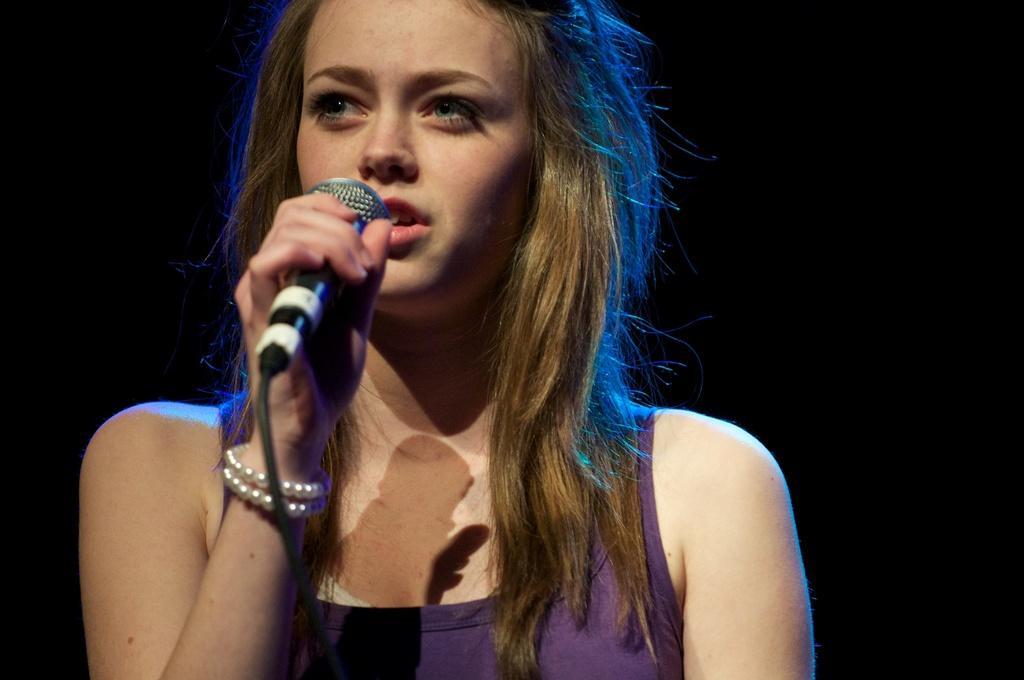Can you describe this image briefly? In this picture we can see woman holding mic in her hand and singing and in background it is dark. 